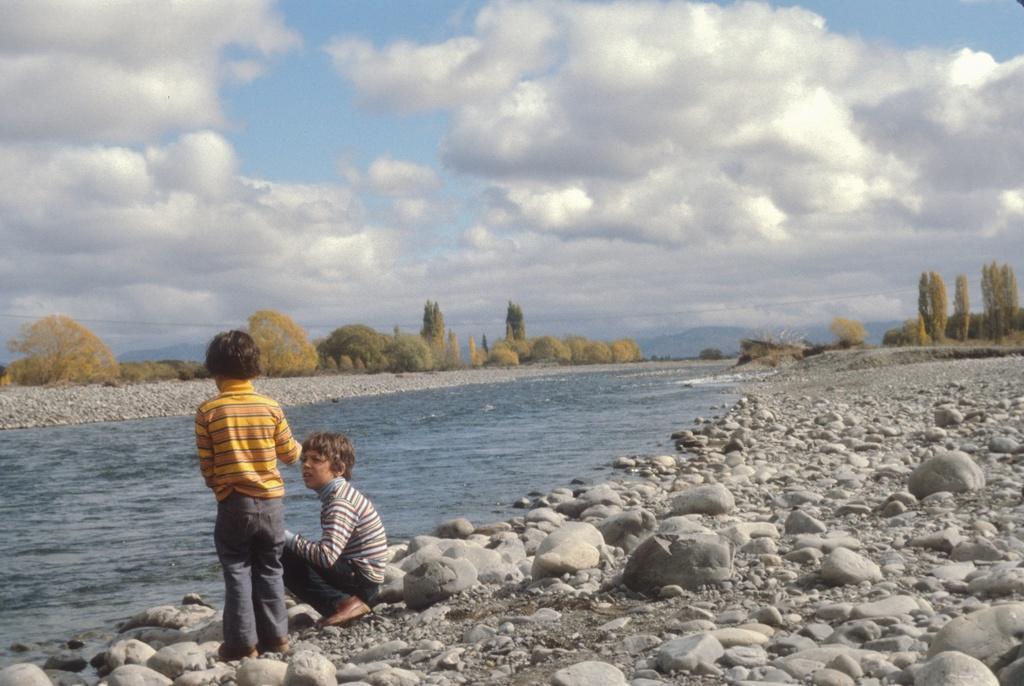Could you give a brief overview of what you see in this image? This picture is clicked outside. In the foreground we can see the rocks and a water body and we can see a kid seems to be sitting on the rock and we can see a kid standing on the ground. In the background we can see the sky with the clouds and we can see the rocks, trees and plants. 